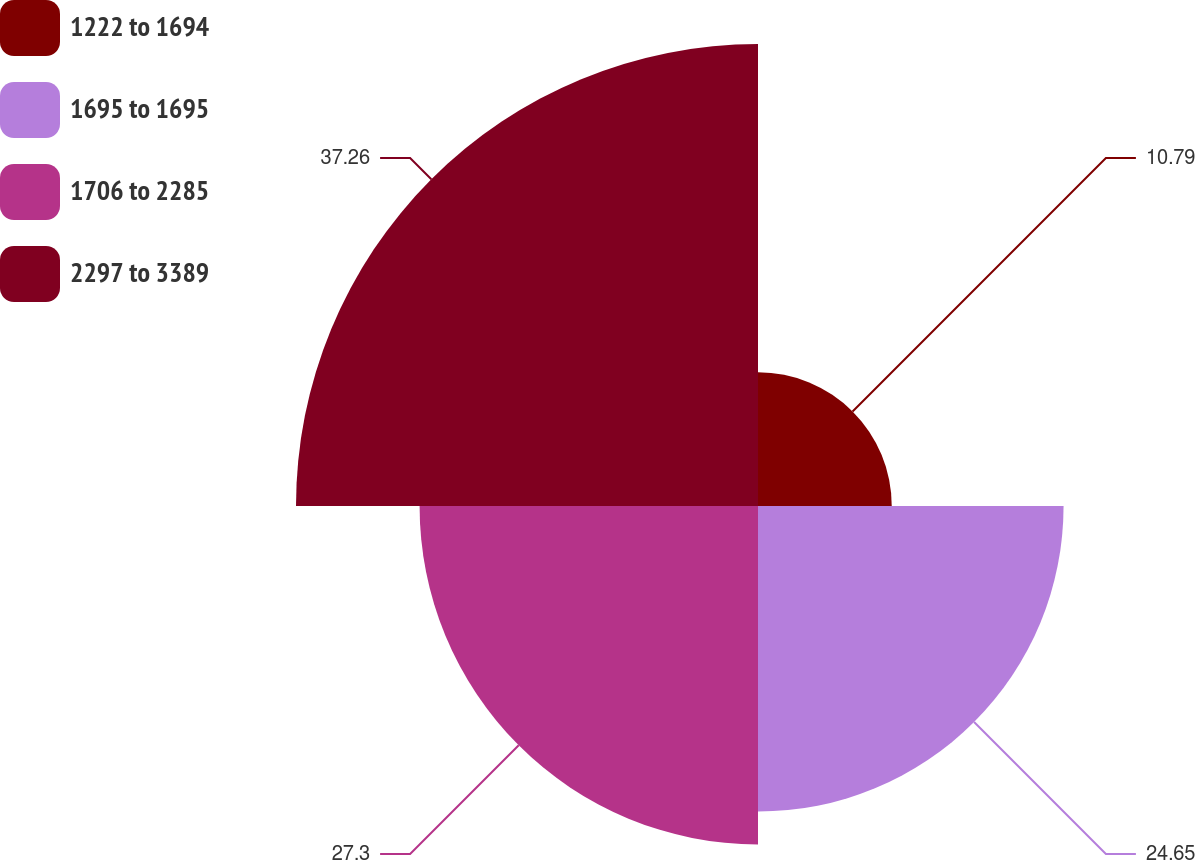<chart> <loc_0><loc_0><loc_500><loc_500><pie_chart><fcel>1222 to 1694<fcel>1695 to 1695<fcel>1706 to 2285<fcel>2297 to 3389<nl><fcel>10.79%<fcel>24.65%<fcel>27.3%<fcel>37.27%<nl></chart> 